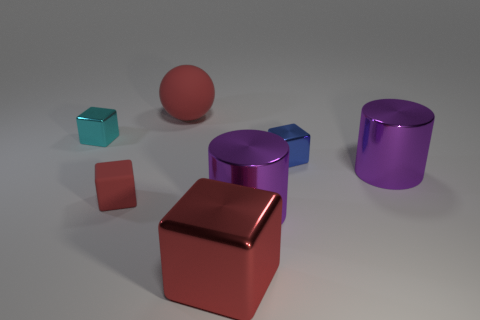What is the lighting condition in the scene? The lighting in the scene is soft and diffused, coming from above. There are subtle shadows under the objects, indicating the light source is not directly overhead. Can you infer the time of day or type of light used? Given the controlled shadows and neutral background, it's likely an artificial light source in a studio setting, rather than natural light. 